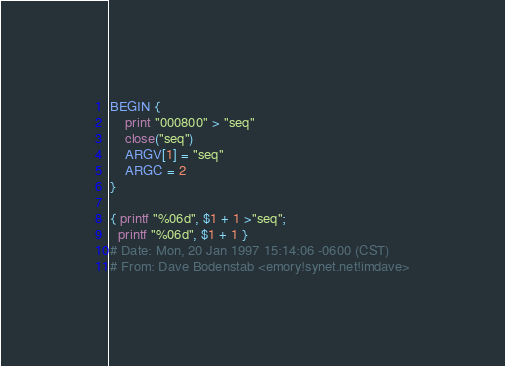Convert code to text. <code><loc_0><loc_0><loc_500><loc_500><_Awk_>BEGIN {
	print "000800" > "seq"
	close("seq")
	ARGV[1] = "seq"
	ARGC = 2
}

{ printf "%06d", $1 + 1 >"seq";
  printf "%06d", $1 + 1 }
# Date: Mon, 20 Jan 1997 15:14:06 -0600 (CST)
# From: Dave Bodenstab <emory!synet.net!imdave></code> 